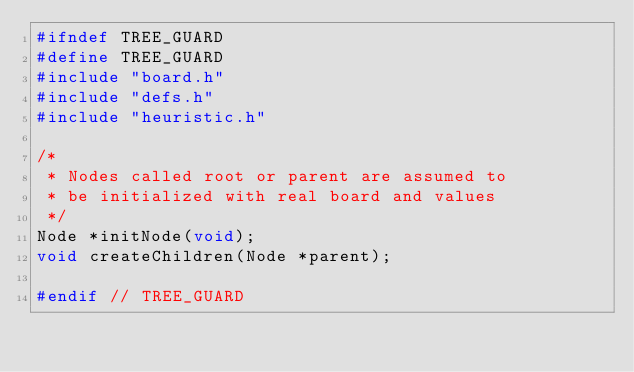<code> <loc_0><loc_0><loc_500><loc_500><_C_>#ifndef TREE_GUARD
#define TREE_GUARD
#include "board.h"
#include "defs.h"
#include "heuristic.h"

/*
 * Nodes called root or parent are assumed to
 * be initialized with real board and values
 */
Node *initNode(void);
void createChildren(Node *parent);

#endif // TREE_GUARD

</code> 